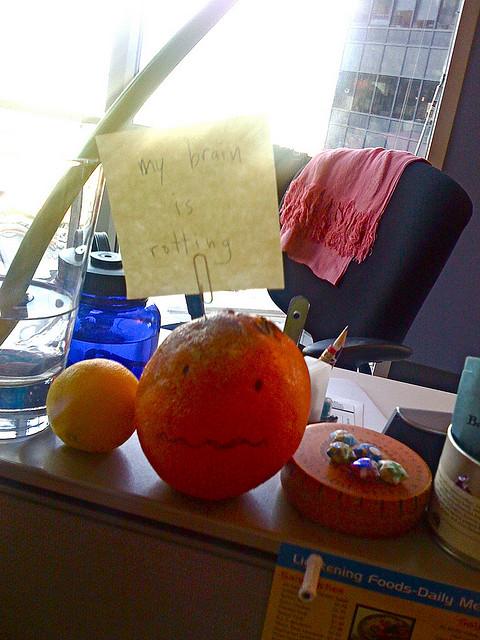Is this fruit fresh?
Quick response, please. No. What does the note say?
Give a very brief answer. My brain is rotting. What fruits are shown?
Quick response, please. Oranges. 